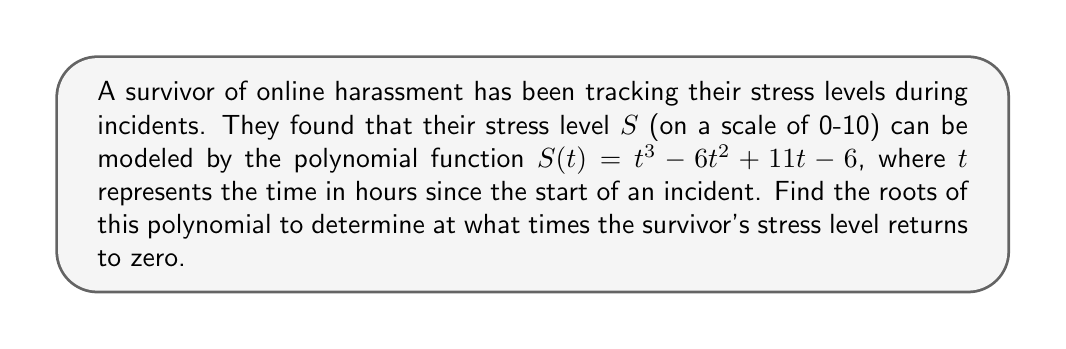Teach me how to tackle this problem. To find the roots of the polynomial $S(t) = t^3 - 6t^2 + 11t - 6$, we need to solve the equation $S(t) = 0$:

1) First, let's check if there are any rational roots using the rational root theorem. The possible rational roots are the factors of the constant term: ±1, ±2, ±3, ±6.

2) Testing these values, we find that $t = 1$ is a root:
   $S(1) = 1^3 - 6(1)^2 + 11(1) - 6 = 1 - 6 + 11 - 6 = 0$

3) Since $t = 1$ is a root, $(t - 1)$ is a factor of $S(t)$. We can use polynomial long division to find the other factor:

   $t^3 - 6t^2 + 11t - 6 = (t - 1)(t^2 - 5t + 6)$

4) Now we need to solve $t^2 - 5t + 6 = 0$. This is a quadratic equation that we can solve using the quadratic formula:

   $t = \frac{-b \pm \sqrt{b^2 - 4ac}}{2a}$

   Where $a = 1$, $b = -5$, and $c = 6$

5) Substituting these values:

   $t = \frac{5 \pm \sqrt{25 - 24}}{2} = \frac{5 \pm 1}{2}$

6) This gives us two more roots:

   $t = \frac{5 + 1}{2} = 3$ and $t = \frac{5 - 1}{2} = 2$

Therefore, the roots of the polynomial are $t = 1$, $t = 2$, and $t = 3$.
Answer: The roots of the polynomial are $t = 1$, $t = 2$, and $t = 3$. This means the survivor's stress level returns to zero at 1 hour, 2 hours, and 3 hours after the start of the incident. 